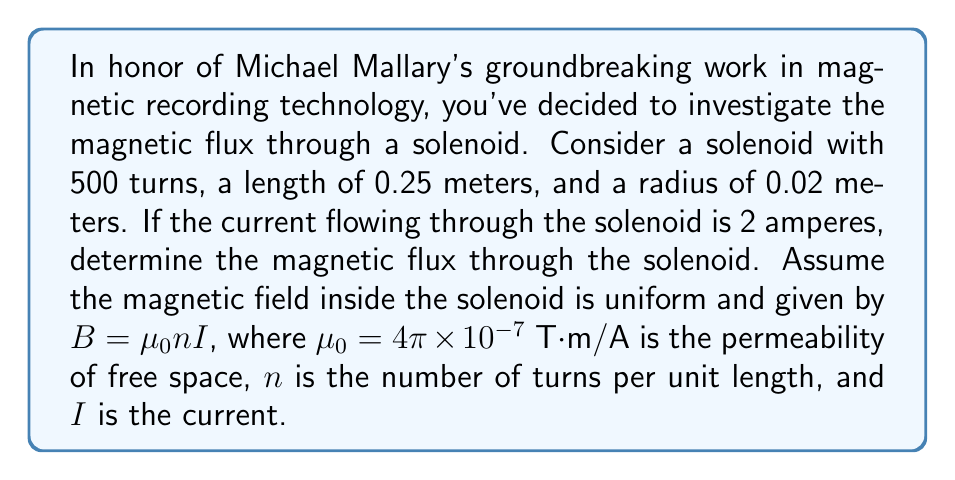Give your solution to this math problem. To solve this problem, let's follow these steps:

1) First, we need to calculate the number of turns per unit length, $n$:
   $n = \frac{\text{total turns}}{\text{length}} = \frac{500}{0.25} = 2000$ turns/m

2) Now we can calculate the magnetic field $B$ inside the solenoid:
   $B = \mu_0 n I = (4\pi \times 10^{-7})(2000)(2) = 5.03 \times 10^{-3}$ T

3) The magnetic flux $\Phi$ is given by the integral:
   $$\Phi = \int \vec{B} \cdot d\vec{A}$$

4) Since the magnetic field is uniform and perpendicular to the cross-sectional area of the solenoid, this simplifies to:
   $$\Phi = B \int dA = BA$$

5) The area $A$ is the circular cross-section of the solenoid:
   $A = \pi r^2 = \pi (0.02)^2 = 1.26 \times 10^{-3}$ m²

6) Finally, we can calculate the flux:
   $$\Phi = BA = (5.03 \times 10^{-3})(1.26 \times 10^{-3}) = 6.33 \times 10^{-6}$$ Wb

Thus, the magnetic flux through the solenoid is $6.33 \times 10^{-6}$ Wb (Weber).
Answer: $6.33 \times 10^{-6}$ Wb 